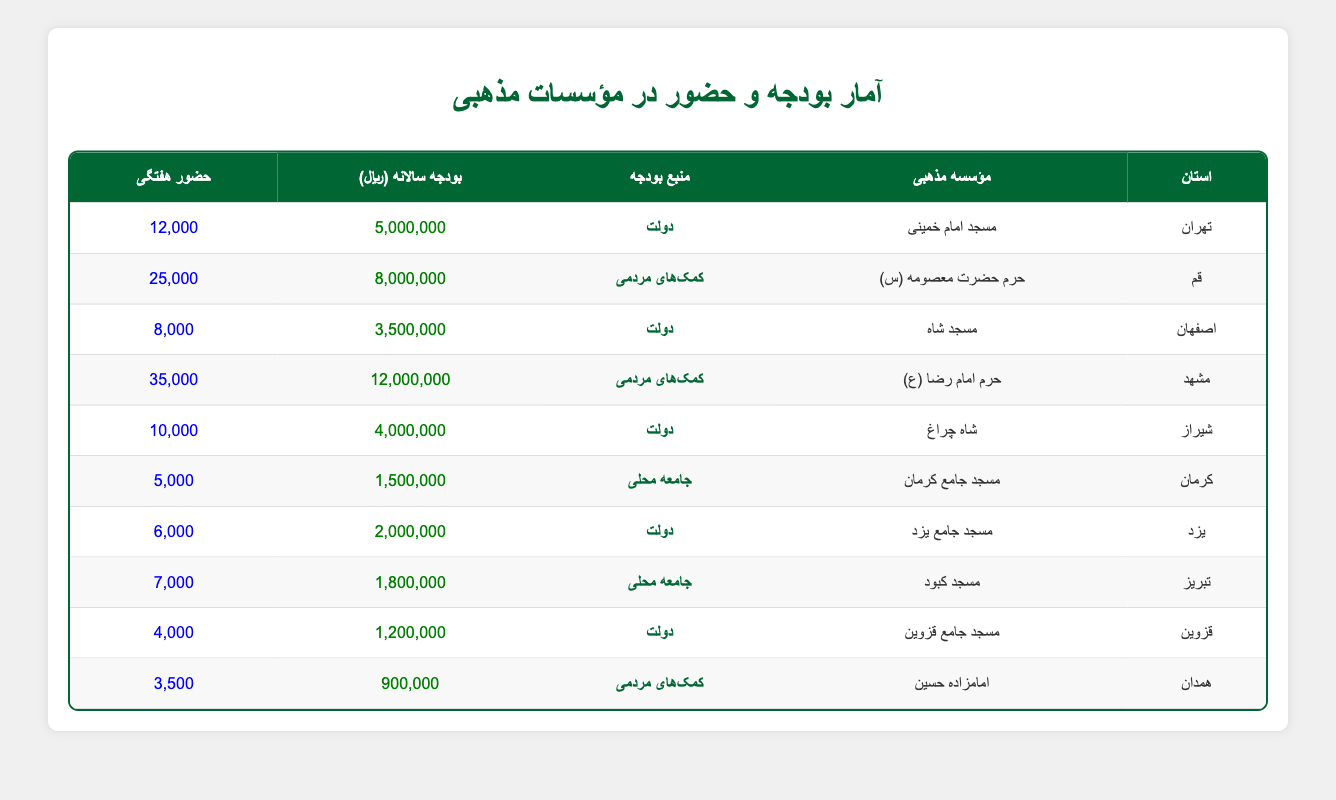What is the annual funding for the Imam Reza Shrine in Mashhad? The table indicates that the Imam Reza Shrine located in Mashhad received an annual funding of 12,000,000.
Answer: 12,000,000 Which province has the highest weekly attendance at a religious institution? According to the table, Mashhad has the highest weekly attendance at 35,000 for the Imam Reza Shrine, compared to other institutions listed.
Answer: Mashhad What is the total annual funding received by the government-funded religious institutions? The government-funded religious institutions are located in Tehran (5,000,000), Isfahan (3,500,000), Shiraz (4,000,000), Yazd (2,000,000), and Qazvin (1,200,000). Adding these amounts gives a total funding of (5,000,000 + 3,500,000 + 4,000,000 + 2,000,000 + 1,200,000) = 15,700,000.
Answer: 15,700,000 Is the Fatima Masumeh Shrine funded by donations? The Fatima Masumeh Shrine in Qom specifically lists its funding source as "Donations" in the table.
Answer: Yes Which city has the lowest annual funding? From the table, Kerman with the Jameh Mosque of Kerman has the lowest annual funding of 1,500,000, compared to others in the list.
Answer: Kerman 